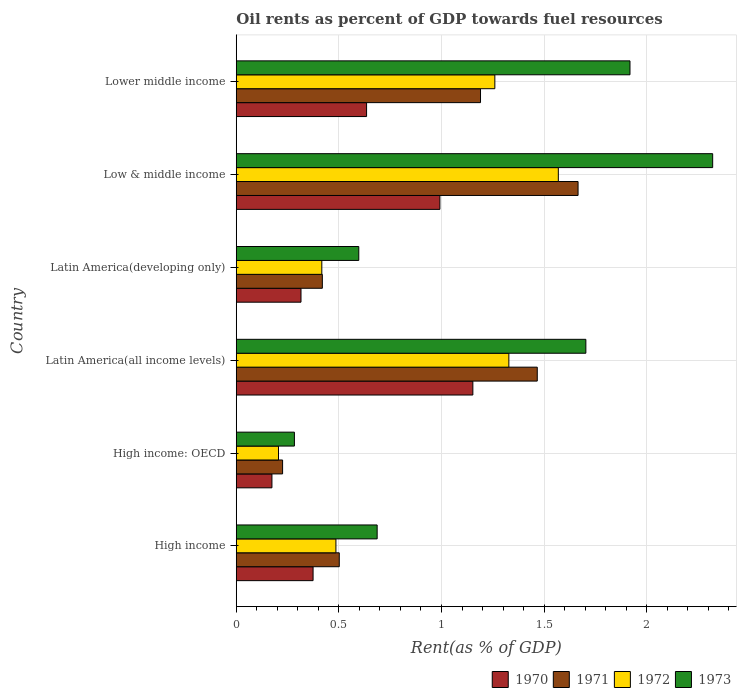How many groups of bars are there?
Offer a terse response. 6. How many bars are there on the 5th tick from the bottom?
Provide a succinct answer. 4. What is the label of the 4th group of bars from the top?
Make the answer very short. Latin America(all income levels). In how many cases, is the number of bars for a given country not equal to the number of legend labels?
Your response must be concise. 0. What is the oil rent in 1972 in Lower middle income?
Your response must be concise. 1.26. Across all countries, what is the maximum oil rent in 1972?
Offer a very short reply. 1.57. Across all countries, what is the minimum oil rent in 1970?
Your answer should be compact. 0.17. In which country was the oil rent in 1971 maximum?
Your answer should be compact. Low & middle income. In which country was the oil rent in 1972 minimum?
Make the answer very short. High income: OECD. What is the total oil rent in 1972 in the graph?
Offer a terse response. 5.27. What is the difference between the oil rent in 1973 in High income and that in Lower middle income?
Your answer should be compact. -1.23. What is the difference between the oil rent in 1971 in Latin America(developing only) and the oil rent in 1972 in High income: OECD?
Your response must be concise. 0.21. What is the average oil rent in 1972 per country?
Keep it short and to the point. 0.88. What is the difference between the oil rent in 1970 and oil rent in 1973 in High income?
Your answer should be compact. -0.31. In how many countries, is the oil rent in 1972 greater than 0.4 %?
Offer a very short reply. 5. What is the ratio of the oil rent in 1970 in Latin America(developing only) to that in Lower middle income?
Your answer should be compact. 0.5. Is the oil rent in 1972 in High income: OECD less than that in Low & middle income?
Provide a short and direct response. Yes. What is the difference between the highest and the second highest oil rent in 1970?
Offer a very short reply. 0.16. What is the difference between the highest and the lowest oil rent in 1971?
Provide a succinct answer. 1.44. In how many countries, is the oil rent in 1971 greater than the average oil rent in 1971 taken over all countries?
Your answer should be very brief. 3. Is it the case that in every country, the sum of the oil rent in 1972 and oil rent in 1971 is greater than the sum of oil rent in 1973 and oil rent in 1970?
Your answer should be very brief. No. What does the 1st bar from the top in High income represents?
Your response must be concise. 1973. What does the 2nd bar from the bottom in High income: OECD represents?
Give a very brief answer. 1971. Is it the case that in every country, the sum of the oil rent in 1972 and oil rent in 1970 is greater than the oil rent in 1973?
Offer a very short reply. No. How many bars are there?
Your response must be concise. 24. Are all the bars in the graph horizontal?
Your answer should be very brief. Yes. How many countries are there in the graph?
Your response must be concise. 6. What is the difference between two consecutive major ticks on the X-axis?
Ensure brevity in your answer.  0.5. How many legend labels are there?
Offer a terse response. 4. What is the title of the graph?
Your response must be concise. Oil rents as percent of GDP towards fuel resources. What is the label or title of the X-axis?
Provide a succinct answer. Rent(as % of GDP). What is the Rent(as % of GDP) in 1970 in High income?
Offer a terse response. 0.37. What is the Rent(as % of GDP) of 1971 in High income?
Provide a short and direct response. 0.5. What is the Rent(as % of GDP) in 1972 in High income?
Provide a succinct answer. 0.49. What is the Rent(as % of GDP) of 1973 in High income?
Ensure brevity in your answer.  0.69. What is the Rent(as % of GDP) of 1970 in High income: OECD?
Give a very brief answer. 0.17. What is the Rent(as % of GDP) in 1971 in High income: OECD?
Your answer should be compact. 0.23. What is the Rent(as % of GDP) in 1972 in High income: OECD?
Provide a short and direct response. 0.21. What is the Rent(as % of GDP) in 1973 in High income: OECD?
Give a very brief answer. 0.28. What is the Rent(as % of GDP) of 1970 in Latin America(all income levels)?
Your response must be concise. 1.15. What is the Rent(as % of GDP) in 1971 in Latin America(all income levels)?
Give a very brief answer. 1.47. What is the Rent(as % of GDP) in 1972 in Latin America(all income levels)?
Offer a very short reply. 1.33. What is the Rent(as % of GDP) in 1973 in Latin America(all income levels)?
Provide a short and direct response. 1.7. What is the Rent(as % of GDP) of 1970 in Latin America(developing only)?
Your answer should be compact. 0.32. What is the Rent(as % of GDP) in 1971 in Latin America(developing only)?
Provide a succinct answer. 0.42. What is the Rent(as % of GDP) in 1972 in Latin America(developing only)?
Offer a terse response. 0.42. What is the Rent(as % of GDP) in 1973 in Latin America(developing only)?
Provide a succinct answer. 0.6. What is the Rent(as % of GDP) in 1970 in Low & middle income?
Your response must be concise. 0.99. What is the Rent(as % of GDP) in 1971 in Low & middle income?
Your answer should be very brief. 1.67. What is the Rent(as % of GDP) in 1972 in Low & middle income?
Your answer should be very brief. 1.57. What is the Rent(as % of GDP) of 1973 in Low & middle income?
Ensure brevity in your answer.  2.32. What is the Rent(as % of GDP) in 1970 in Lower middle income?
Provide a succinct answer. 0.63. What is the Rent(as % of GDP) in 1971 in Lower middle income?
Your answer should be compact. 1.19. What is the Rent(as % of GDP) of 1972 in Lower middle income?
Your response must be concise. 1.26. What is the Rent(as % of GDP) in 1973 in Lower middle income?
Provide a succinct answer. 1.92. Across all countries, what is the maximum Rent(as % of GDP) in 1970?
Your answer should be compact. 1.15. Across all countries, what is the maximum Rent(as % of GDP) in 1971?
Keep it short and to the point. 1.67. Across all countries, what is the maximum Rent(as % of GDP) of 1972?
Ensure brevity in your answer.  1.57. Across all countries, what is the maximum Rent(as % of GDP) of 1973?
Your answer should be compact. 2.32. Across all countries, what is the minimum Rent(as % of GDP) of 1970?
Give a very brief answer. 0.17. Across all countries, what is the minimum Rent(as % of GDP) of 1971?
Keep it short and to the point. 0.23. Across all countries, what is the minimum Rent(as % of GDP) of 1972?
Provide a short and direct response. 0.21. Across all countries, what is the minimum Rent(as % of GDP) of 1973?
Your response must be concise. 0.28. What is the total Rent(as % of GDP) in 1970 in the graph?
Your response must be concise. 3.64. What is the total Rent(as % of GDP) of 1971 in the graph?
Offer a very short reply. 5.47. What is the total Rent(as % of GDP) of 1972 in the graph?
Your answer should be very brief. 5.27. What is the total Rent(as % of GDP) of 1973 in the graph?
Ensure brevity in your answer.  7.51. What is the difference between the Rent(as % of GDP) in 1970 in High income and that in High income: OECD?
Offer a very short reply. 0.2. What is the difference between the Rent(as % of GDP) in 1971 in High income and that in High income: OECD?
Your answer should be very brief. 0.28. What is the difference between the Rent(as % of GDP) of 1972 in High income and that in High income: OECD?
Offer a terse response. 0.28. What is the difference between the Rent(as % of GDP) of 1973 in High income and that in High income: OECD?
Your response must be concise. 0.4. What is the difference between the Rent(as % of GDP) in 1970 in High income and that in Latin America(all income levels)?
Your answer should be compact. -0.78. What is the difference between the Rent(as % of GDP) of 1971 in High income and that in Latin America(all income levels)?
Offer a terse response. -0.96. What is the difference between the Rent(as % of GDP) in 1972 in High income and that in Latin America(all income levels)?
Offer a very short reply. -0.84. What is the difference between the Rent(as % of GDP) in 1973 in High income and that in Latin America(all income levels)?
Ensure brevity in your answer.  -1.02. What is the difference between the Rent(as % of GDP) of 1970 in High income and that in Latin America(developing only)?
Offer a very short reply. 0.06. What is the difference between the Rent(as % of GDP) of 1971 in High income and that in Latin America(developing only)?
Your response must be concise. 0.08. What is the difference between the Rent(as % of GDP) in 1972 in High income and that in Latin America(developing only)?
Your answer should be compact. 0.07. What is the difference between the Rent(as % of GDP) of 1973 in High income and that in Latin America(developing only)?
Keep it short and to the point. 0.09. What is the difference between the Rent(as % of GDP) of 1970 in High income and that in Low & middle income?
Offer a terse response. -0.62. What is the difference between the Rent(as % of GDP) of 1971 in High income and that in Low & middle income?
Provide a short and direct response. -1.16. What is the difference between the Rent(as % of GDP) of 1972 in High income and that in Low & middle income?
Give a very brief answer. -1.08. What is the difference between the Rent(as % of GDP) in 1973 in High income and that in Low & middle income?
Provide a short and direct response. -1.63. What is the difference between the Rent(as % of GDP) of 1970 in High income and that in Lower middle income?
Your response must be concise. -0.26. What is the difference between the Rent(as % of GDP) in 1971 in High income and that in Lower middle income?
Give a very brief answer. -0.69. What is the difference between the Rent(as % of GDP) of 1972 in High income and that in Lower middle income?
Your answer should be compact. -0.77. What is the difference between the Rent(as % of GDP) of 1973 in High income and that in Lower middle income?
Provide a short and direct response. -1.23. What is the difference between the Rent(as % of GDP) of 1970 in High income: OECD and that in Latin America(all income levels)?
Keep it short and to the point. -0.98. What is the difference between the Rent(as % of GDP) of 1971 in High income: OECD and that in Latin America(all income levels)?
Offer a very short reply. -1.24. What is the difference between the Rent(as % of GDP) of 1972 in High income: OECD and that in Latin America(all income levels)?
Provide a succinct answer. -1.12. What is the difference between the Rent(as % of GDP) of 1973 in High income: OECD and that in Latin America(all income levels)?
Ensure brevity in your answer.  -1.42. What is the difference between the Rent(as % of GDP) of 1970 in High income: OECD and that in Latin America(developing only)?
Keep it short and to the point. -0.14. What is the difference between the Rent(as % of GDP) in 1971 in High income: OECD and that in Latin America(developing only)?
Offer a very short reply. -0.19. What is the difference between the Rent(as % of GDP) of 1972 in High income: OECD and that in Latin America(developing only)?
Give a very brief answer. -0.21. What is the difference between the Rent(as % of GDP) of 1973 in High income: OECD and that in Latin America(developing only)?
Keep it short and to the point. -0.31. What is the difference between the Rent(as % of GDP) of 1970 in High income: OECD and that in Low & middle income?
Your response must be concise. -0.82. What is the difference between the Rent(as % of GDP) of 1971 in High income: OECD and that in Low & middle income?
Provide a short and direct response. -1.44. What is the difference between the Rent(as % of GDP) in 1972 in High income: OECD and that in Low & middle income?
Ensure brevity in your answer.  -1.36. What is the difference between the Rent(as % of GDP) of 1973 in High income: OECD and that in Low & middle income?
Give a very brief answer. -2.04. What is the difference between the Rent(as % of GDP) in 1970 in High income: OECD and that in Lower middle income?
Your answer should be compact. -0.46. What is the difference between the Rent(as % of GDP) in 1971 in High income: OECD and that in Lower middle income?
Keep it short and to the point. -0.96. What is the difference between the Rent(as % of GDP) of 1972 in High income: OECD and that in Lower middle income?
Your answer should be very brief. -1.05. What is the difference between the Rent(as % of GDP) in 1973 in High income: OECD and that in Lower middle income?
Provide a succinct answer. -1.64. What is the difference between the Rent(as % of GDP) in 1970 in Latin America(all income levels) and that in Latin America(developing only)?
Give a very brief answer. 0.84. What is the difference between the Rent(as % of GDP) in 1971 in Latin America(all income levels) and that in Latin America(developing only)?
Provide a succinct answer. 1.05. What is the difference between the Rent(as % of GDP) in 1972 in Latin America(all income levels) and that in Latin America(developing only)?
Your answer should be very brief. 0.91. What is the difference between the Rent(as % of GDP) in 1973 in Latin America(all income levels) and that in Latin America(developing only)?
Keep it short and to the point. 1.11. What is the difference between the Rent(as % of GDP) of 1970 in Latin America(all income levels) and that in Low & middle income?
Your response must be concise. 0.16. What is the difference between the Rent(as % of GDP) of 1971 in Latin America(all income levels) and that in Low & middle income?
Give a very brief answer. -0.2. What is the difference between the Rent(as % of GDP) of 1972 in Latin America(all income levels) and that in Low & middle income?
Keep it short and to the point. -0.24. What is the difference between the Rent(as % of GDP) of 1973 in Latin America(all income levels) and that in Low & middle income?
Your answer should be compact. -0.62. What is the difference between the Rent(as % of GDP) of 1970 in Latin America(all income levels) and that in Lower middle income?
Offer a very short reply. 0.52. What is the difference between the Rent(as % of GDP) in 1971 in Latin America(all income levels) and that in Lower middle income?
Provide a succinct answer. 0.28. What is the difference between the Rent(as % of GDP) of 1972 in Latin America(all income levels) and that in Lower middle income?
Make the answer very short. 0.07. What is the difference between the Rent(as % of GDP) of 1973 in Latin America(all income levels) and that in Lower middle income?
Offer a very short reply. -0.21. What is the difference between the Rent(as % of GDP) of 1970 in Latin America(developing only) and that in Low & middle income?
Ensure brevity in your answer.  -0.68. What is the difference between the Rent(as % of GDP) in 1971 in Latin America(developing only) and that in Low & middle income?
Offer a terse response. -1.25. What is the difference between the Rent(as % of GDP) in 1972 in Latin America(developing only) and that in Low & middle income?
Your response must be concise. -1.15. What is the difference between the Rent(as % of GDP) in 1973 in Latin America(developing only) and that in Low & middle income?
Give a very brief answer. -1.72. What is the difference between the Rent(as % of GDP) of 1970 in Latin America(developing only) and that in Lower middle income?
Provide a succinct answer. -0.32. What is the difference between the Rent(as % of GDP) in 1971 in Latin America(developing only) and that in Lower middle income?
Offer a terse response. -0.77. What is the difference between the Rent(as % of GDP) of 1972 in Latin America(developing only) and that in Lower middle income?
Your answer should be compact. -0.84. What is the difference between the Rent(as % of GDP) in 1973 in Latin America(developing only) and that in Lower middle income?
Make the answer very short. -1.32. What is the difference between the Rent(as % of GDP) of 1970 in Low & middle income and that in Lower middle income?
Offer a terse response. 0.36. What is the difference between the Rent(as % of GDP) of 1971 in Low & middle income and that in Lower middle income?
Offer a very short reply. 0.48. What is the difference between the Rent(as % of GDP) of 1972 in Low & middle income and that in Lower middle income?
Give a very brief answer. 0.31. What is the difference between the Rent(as % of GDP) of 1973 in Low & middle income and that in Lower middle income?
Your response must be concise. 0.4. What is the difference between the Rent(as % of GDP) in 1970 in High income and the Rent(as % of GDP) in 1971 in High income: OECD?
Your response must be concise. 0.15. What is the difference between the Rent(as % of GDP) of 1970 in High income and the Rent(as % of GDP) of 1972 in High income: OECD?
Your answer should be very brief. 0.17. What is the difference between the Rent(as % of GDP) of 1970 in High income and the Rent(as % of GDP) of 1973 in High income: OECD?
Give a very brief answer. 0.09. What is the difference between the Rent(as % of GDP) in 1971 in High income and the Rent(as % of GDP) in 1972 in High income: OECD?
Offer a terse response. 0.3. What is the difference between the Rent(as % of GDP) of 1971 in High income and the Rent(as % of GDP) of 1973 in High income: OECD?
Provide a short and direct response. 0.22. What is the difference between the Rent(as % of GDP) of 1972 in High income and the Rent(as % of GDP) of 1973 in High income: OECD?
Your answer should be compact. 0.2. What is the difference between the Rent(as % of GDP) in 1970 in High income and the Rent(as % of GDP) in 1971 in Latin America(all income levels)?
Your answer should be compact. -1.09. What is the difference between the Rent(as % of GDP) in 1970 in High income and the Rent(as % of GDP) in 1972 in Latin America(all income levels)?
Your answer should be very brief. -0.95. What is the difference between the Rent(as % of GDP) of 1970 in High income and the Rent(as % of GDP) of 1973 in Latin America(all income levels)?
Give a very brief answer. -1.33. What is the difference between the Rent(as % of GDP) in 1971 in High income and the Rent(as % of GDP) in 1972 in Latin America(all income levels)?
Provide a short and direct response. -0.83. What is the difference between the Rent(as % of GDP) in 1971 in High income and the Rent(as % of GDP) in 1973 in Latin America(all income levels)?
Offer a very short reply. -1.2. What is the difference between the Rent(as % of GDP) of 1972 in High income and the Rent(as % of GDP) of 1973 in Latin America(all income levels)?
Offer a very short reply. -1.22. What is the difference between the Rent(as % of GDP) of 1970 in High income and the Rent(as % of GDP) of 1971 in Latin America(developing only)?
Offer a very short reply. -0.05. What is the difference between the Rent(as % of GDP) of 1970 in High income and the Rent(as % of GDP) of 1972 in Latin America(developing only)?
Your answer should be compact. -0.04. What is the difference between the Rent(as % of GDP) in 1970 in High income and the Rent(as % of GDP) in 1973 in Latin America(developing only)?
Offer a terse response. -0.22. What is the difference between the Rent(as % of GDP) of 1971 in High income and the Rent(as % of GDP) of 1972 in Latin America(developing only)?
Your response must be concise. 0.09. What is the difference between the Rent(as % of GDP) in 1971 in High income and the Rent(as % of GDP) in 1973 in Latin America(developing only)?
Your answer should be compact. -0.1. What is the difference between the Rent(as % of GDP) in 1972 in High income and the Rent(as % of GDP) in 1973 in Latin America(developing only)?
Give a very brief answer. -0.11. What is the difference between the Rent(as % of GDP) in 1970 in High income and the Rent(as % of GDP) in 1971 in Low & middle income?
Give a very brief answer. -1.29. What is the difference between the Rent(as % of GDP) in 1970 in High income and the Rent(as % of GDP) in 1972 in Low & middle income?
Provide a short and direct response. -1.19. What is the difference between the Rent(as % of GDP) of 1970 in High income and the Rent(as % of GDP) of 1973 in Low & middle income?
Ensure brevity in your answer.  -1.95. What is the difference between the Rent(as % of GDP) of 1971 in High income and the Rent(as % of GDP) of 1972 in Low & middle income?
Make the answer very short. -1.07. What is the difference between the Rent(as % of GDP) of 1971 in High income and the Rent(as % of GDP) of 1973 in Low & middle income?
Keep it short and to the point. -1.82. What is the difference between the Rent(as % of GDP) of 1972 in High income and the Rent(as % of GDP) of 1973 in Low & middle income?
Make the answer very short. -1.84. What is the difference between the Rent(as % of GDP) in 1970 in High income and the Rent(as % of GDP) in 1971 in Lower middle income?
Your answer should be compact. -0.82. What is the difference between the Rent(as % of GDP) in 1970 in High income and the Rent(as % of GDP) in 1972 in Lower middle income?
Your response must be concise. -0.89. What is the difference between the Rent(as % of GDP) in 1970 in High income and the Rent(as % of GDP) in 1973 in Lower middle income?
Your answer should be very brief. -1.54. What is the difference between the Rent(as % of GDP) in 1971 in High income and the Rent(as % of GDP) in 1972 in Lower middle income?
Offer a terse response. -0.76. What is the difference between the Rent(as % of GDP) of 1971 in High income and the Rent(as % of GDP) of 1973 in Lower middle income?
Provide a short and direct response. -1.42. What is the difference between the Rent(as % of GDP) in 1972 in High income and the Rent(as % of GDP) in 1973 in Lower middle income?
Offer a terse response. -1.43. What is the difference between the Rent(as % of GDP) in 1970 in High income: OECD and the Rent(as % of GDP) in 1971 in Latin America(all income levels)?
Your response must be concise. -1.29. What is the difference between the Rent(as % of GDP) of 1970 in High income: OECD and the Rent(as % of GDP) of 1972 in Latin America(all income levels)?
Give a very brief answer. -1.15. What is the difference between the Rent(as % of GDP) of 1970 in High income: OECD and the Rent(as % of GDP) of 1973 in Latin America(all income levels)?
Offer a very short reply. -1.53. What is the difference between the Rent(as % of GDP) of 1971 in High income: OECD and the Rent(as % of GDP) of 1972 in Latin America(all income levels)?
Your response must be concise. -1.1. What is the difference between the Rent(as % of GDP) in 1971 in High income: OECD and the Rent(as % of GDP) in 1973 in Latin America(all income levels)?
Make the answer very short. -1.48. What is the difference between the Rent(as % of GDP) in 1972 in High income: OECD and the Rent(as % of GDP) in 1973 in Latin America(all income levels)?
Make the answer very short. -1.5. What is the difference between the Rent(as % of GDP) of 1970 in High income: OECD and the Rent(as % of GDP) of 1971 in Latin America(developing only)?
Your response must be concise. -0.25. What is the difference between the Rent(as % of GDP) of 1970 in High income: OECD and the Rent(as % of GDP) of 1972 in Latin America(developing only)?
Ensure brevity in your answer.  -0.24. What is the difference between the Rent(as % of GDP) in 1970 in High income: OECD and the Rent(as % of GDP) in 1973 in Latin America(developing only)?
Provide a succinct answer. -0.42. What is the difference between the Rent(as % of GDP) of 1971 in High income: OECD and the Rent(as % of GDP) of 1972 in Latin America(developing only)?
Your answer should be compact. -0.19. What is the difference between the Rent(as % of GDP) of 1971 in High income: OECD and the Rent(as % of GDP) of 1973 in Latin America(developing only)?
Offer a terse response. -0.37. What is the difference between the Rent(as % of GDP) of 1972 in High income: OECD and the Rent(as % of GDP) of 1973 in Latin America(developing only)?
Provide a short and direct response. -0.39. What is the difference between the Rent(as % of GDP) of 1970 in High income: OECD and the Rent(as % of GDP) of 1971 in Low & middle income?
Make the answer very short. -1.49. What is the difference between the Rent(as % of GDP) of 1970 in High income: OECD and the Rent(as % of GDP) of 1972 in Low & middle income?
Make the answer very short. -1.4. What is the difference between the Rent(as % of GDP) of 1970 in High income: OECD and the Rent(as % of GDP) of 1973 in Low & middle income?
Provide a succinct answer. -2.15. What is the difference between the Rent(as % of GDP) in 1971 in High income: OECD and the Rent(as % of GDP) in 1972 in Low & middle income?
Keep it short and to the point. -1.34. What is the difference between the Rent(as % of GDP) of 1971 in High income: OECD and the Rent(as % of GDP) of 1973 in Low & middle income?
Keep it short and to the point. -2.1. What is the difference between the Rent(as % of GDP) in 1972 in High income: OECD and the Rent(as % of GDP) in 1973 in Low & middle income?
Give a very brief answer. -2.12. What is the difference between the Rent(as % of GDP) of 1970 in High income: OECD and the Rent(as % of GDP) of 1971 in Lower middle income?
Offer a terse response. -1.02. What is the difference between the Rent(as % of GDP) of 1970 in High income: OECD and the Rent(as % of GDP) of 1972 in Lower middle income?
Your response must be concise. -1.09. What is the difference between the Rent(as % of GDP) of 1970 in High income: OECD and the Rent(as % of GDP) of 1973 in Lower middle income?
Give a very brief answer. -1.74. What is the difference between the Rent(as % of GDP) in 1971 in High income: OECD and the Rent(as % of GDP) in 1972 in Lower middle income?
Provide a short and direct response. -1.03. What is the difference between the Rent(as % of GDP) in 1971 in High income: OECD and the Rent(as % of GDP) in 1973 in Lower middle income?
Your response must be concise. -1.69. What is the difference between the Rent(as % of GDP) of 1972 in High income: OECD and the Rent(as % of GDP) of 1973 in Lower middle income?
Your response must be concise. -1.71. What is the difference between the Rent(as % of GDP) of 1970 in Latin America(all income levels) and the Rent(as % of GDP) of 1971 in Latin America(developing only)?
Provide a short and direct response. 0.73. What is the difference between the Rent(as % of GDP) in 1970 in Latin America(all income levels) and the Rent(as % of GDP) in 1972 in Latin America(developing only)?
Ensure brevity in your answer.  0.74. What is the difference between the Rent(as % of GDP) of 1970 in Latin America(all income levels) and the Rent(as % of GDP) of 1973 in Latin America(developing only)?
Keep it short and to the point. 0.56. What is the difference between the Rent(as % of GDP) of 1971 in Latin America(all income levels) and the Rent(as % of GDP) of 1972 in Latin America(developing only)?
Provide a short and direct response. 1.05. What is the difference between the Rent(as % of GDP) of 1971 in Latin America(all income levels) and the Rent(as % of GDP) of 1973 in Latin America(developing only)?
Keep it short and to the point. 0.87. What is the difference between the Rent(as % of GDP) in 1972 in Latin America(all income levels) and the Rent(as % of GDP) in 1973 in Latin America(developing only)?
Your answer should be very brief. 0.73. What is the difference between the Rent(as % of GDP) of 1970 in Latin America(all income levels) and the Rent(as % of GDP) of 1971 in Low & middle income?
Your response must be concise. -0.51. What is the difference between the Rent(as % of GDP) in 1970 in Latin America(all income levels) and the Rent(as % of GDP) in 1972 in Low & middle income?
Make the answer very short. -0.42. What is the difference between the Rent(as % of GDP) in 1970 in Latin America(all income levels) and the Rent(as % of GDP) in 1973 in Low & middle income?
Your response must be concise. -1.17. What is the difference between the Rent(as % of GDP) in 1971 in Latin America(all income levels) and the Rent(as % of GDP) in 1972 in Low & middle income?
Provide a short and direct response. -0.1. What is the difference between the Rent(as % of GDP) of 1971 in Latin America(all income levels) and the Rent(as % of GDP) of 1973 in Low & middle income?
Give a very brief answer. -0.85. What is the difference between the Rent(as % of GDP) of 1972 in Latin America(all income levels) and the Rent(as % of GDP) of 1973 in Low & middle income?
Provide a succinct answer. -0.99. What is the difference between the Rent(as % of GDP) of 1970 in Latin America(all income levels) and the Rent(as % of GDP) of 1971 in Lower middle income?
Offer a very short reply. -0.04. What is the difference between the Rent(as % of GDP) in 1970 in Latin America(all income levels) and the Rent(as % of GDP) in 1972 in Lower middle income?
Ensure brevity in your answer.  -0.11. What is the difference between the Rent(as % of GDP) of 1970 in Latin America(all income levels) and the Rent(as % of GDP) of 1973 in Lower middle income?
Your answer should be very brief. -0.77. What is the difference between the Rent(as % of GDP) in 1971 in Latin America(all income levels) and the Rent(as % of GDP) in 1972 in Lower middle income?
Your answer should be compact. 0.21. What is the difference between the Rent(as % of GDP) of 1971 in Latin America(all income levels) and the Rent(as % of GDP) of 1973 in Lower middle income?
Your answer should be very brief. -0.45. What is the difference between the Rent(as % of GDP) in 1972 in Latin America(all income levels) and the Rent(as % of GDP) in 1973 in Lower middle income?
Your answer should be very brief. -0.59. What is the difference between the Rent(as % of GDP) in 1970 in Latin America(developing only) and the Rent(as % of GDP) in 1971 in Low & middle income?
Keep it short and to the point. -1.35. What is the difference between the Rent(as % of GDP) of 1970 in Latin America(developing only) and the Rent(as % of GDP) of 1972 in Low & middle income?
Make the answer very short. -1.25. What is the difference between the Rent(as % of GDP) in 1970 in Latin America(developing only) and the Rent(as % of GDP) in 1973 in Low & middle income?
Keep it short and to the point. -2.01. What is the difference between the Rent(as % of GDP) of 1971 in Latin America(developing only) and the Rent(as % of GDP) of 1972 in Low & middle income?
Keep it short and to the point. -1.15. What is the difference between the Rent(as % of GDP) in 1971 in Latin America(developing only) and the Rent(as % of GDP) in 1973 in Low & middle income?
Make the answer very short. -1.9. What is the difference between the Rent(as % of GDP) of 1972 in Latin America(developing only) and the Rent(as % of GDP) of 1973 in Low & middle income?
Offer a terse response. -1.9. What is the difference between the Rent(as % of GDP) of 1970 in Latin America(developing only) and the Rent(as % of GDP) of 1971 in Lower middle income?
Your response must be concise. -0.87. What is the difference between the Rent(as % of GDP) of 1970 in Latin America(developing only) and the Rent(as % of GDP) of 1972 in Lower middle income?
Provide a short and direct response. -0.94. What is the difference between the Rent(as % of GDP) of 1970 in Latin America(developing only) and the Rent(as % of GDP) of 1973 in Lower middle income?
Give a very brief answer. -1.6. What is the difference between the Rent(as % of GDP) in 1971 in Latin America(developing only) and the Rent(as % of GDP) in 1972 in Lower middle income?
Your answer should be compact. -0.84. What is the difference between the Rent(as % of GDP) in 1971 in Latin America(developing only) and the Rent(as % of GDP) in 1973 in Lower middle income?
Your answer should be very brief. -1.5. What is the difference between the Rent(as % of GDP) in 1972 in Latin America(developing only) and the Rent(as % of GDP) in 1973 in Lower middle income?
Your answer should be compact. -1.5. What is the difference between the Rent(as % of GDP) of 1970 in Low & middle income and the Rent(as % of GDP) of 1971 in Lower middle income?
Your response must be concise. -0.2. What is the difference between the Rent(as % of GDP) in 1970 in Low & middle income and the Rent(as % of GDP) in 1972 in Lower middle income?
Offer a very short reply. -0.27. What is the difference between the Rent(as % of GDP) of 1970 in Low & middle income and the Rent(as % of GDP) of 1973 in Lower middle income?
Ensure brevity in your answer.  -0.93. What is the difference between the Rent(as % of GDP) in 1971 in Low & middle income and the Rent(as % of GDP) in 1972 in Lower middle income?
Ensure brevity in your answer.  0.41. What is the difference between the Rent(as % of GDP) of 1971 in Low & middle income and the Rent(as % of GDP) of 1973 in Lower middle income?
Your answer should be compact. -0.25. What is the difference between the Rent(as % of GDP) of 1972 in Low & middle income and the Rent(as % of GDP) of 1973 in Lower middle income?
Provide a short and direct response. -0.35. What is the average Rent(as % of GDP) of 1970 per country?
Offer a terse response. 0.61. What is the average Rent(as % of GDP) of 1971 per country?
Your answer should be very brief. 0.91. What is the average Rent(as % of GDP) in 1972 per country?
Your answer should be compact. 0.88. What is the average Rent(as % of GDP) in 1973 per country?
Your response must be concise. 1.25. What is the difference between the Rent(as % of GDP) in 1970 and Rent(as % of GDP) in 1971 in High income?
Keep it short and to the point. -0.13. What is the difference between the Rent(as % of GDP) in 1970 and Rent(as % of GDP) in 1972 in High income?
Offer a very short reply. -0.11. What is the difference between the Rent(as % of GDP) in 1970 and Rent(as % of GDP) in 1973 in High income?
Your answer should be very brief. -0.31. What is the difference between the Rent(as % of GDP) in 1971 and Rent(as % of GDP) in 1972 in High income?
Your response must be concise. 0.02. What is the difference between the Rent(as % of GDP) of 1971 and Rent(as % of GDP) of 1973 in High income?
Provide a succinct answer. -0.18. What is the difference between the Rent(as % of GDP) in 1972 and Rent(as % of GDP) in 1973 in High income?
Your answer should be very brief. -0.2. What is the difference between the Rent(as % of GDP) of 1970 and Rent(as % of GDP) of 1971 in High income: OECD?
Provide a succinct answer. -0.05. What is the difference between the Rent(as % of GDP) in 1970 and Rent(as % of GDP) in 1972 in High income: OECD?
Give a very brief answer. -0.03. What is the difference between the Rent(as % of GDP) in 1970 and Rent(as % of GDP) in 1973 in High income: OECD?
Keep it short and to the point. -0.11. What is the difference between the Rent(as % of GDP) of 1971 and Rent(as % of GDP) of 1973 in High income: OECD?
Make the answer very short. -0.06. What is the difference between the Rent(as % of GDP) of 1972 and Rent(as % of GDP) of 1973 in High income: OECD?
Your response must be concise. -0.08. What is the difference between the Rent(as % of GDP) of 1970 and Rent(as % of GDP) of 1971 in Latin America(all income levels)?
Keep it short and to the point. -0.31. What is the difference between the Rent(as % of GDP) of 1970 and Rent(as % of GDP) of 1972 in Latin America(all income levels)?
Offer a terse response. -0.18. What is the difference between the Rent(as % of GDP) of 1970 and Rent(as % of GDP) of 1973 in Latin America(all income levels)?
Provide a succinct answer. -0.55. What is the difference between the Rent(as % of GDP) of 1971 and Rent(as % of GDP) of 1972 in Latin America(all income levels)?
Offer a very short reply. 0.14. What is the difference between the Rent(as % of GDP) in 1971 and Rent(as % of GDP) in 1973 in Latin America(all income levels)?
Provide a short and direct response. -0.24. What is the difference between the Rent(as % of GDP) in 1972 and Rent(as % of GDP) in 1973 in Latin America(all income levels)?
Provide a short and direct response. -0.38. What is the difference between the Rent(as % of GDP) of 1970 and Rent(as % of GDP) of 1971 in Latin America(developing only)?
Keep it short and to the point. -0.1. What is the difference between the Rent(as % of GDP) in 1970 and Rent(as % of GDP) in 1972 in Latin America(developing only)?
Your answer should be very brief. -0.1. What is the difference between the Rent(as % of GDP) in 1970 and Rent(as % of GDP) in 1973 in Latin America(developing only)?
Make the answer very short. -0.28. What is the difference between the Rent(as % of GDP) in 1971 and Rent(as % of GDP) in 1972 in Latin America(developing only)?
Your answer should be compact. 0. What is the difference between the Rent(as % of GDP) in 1971 and Rent(as % of GDP) in 1973 in Latin America(developing only)?
Ensure brevity in your answer.  -0.18. What is the difference between the Rent(as % of GDP) of 1972 and Rent(as % of GDP) of 1973 in Latin America(developing only)?
Give a very brief answer. -0.18. What is the difference between the Rent(as % of GDP) of 1970 and Rent(as % of GDP) of 1971 in Low & middle income?
Offer a very short reply. -0.67. What is the difference between the Rent(as % of GDP) of 1970 and Rent(as % of GDP) of 1972 in Low & middle income?
Provide a short and direct response. -0.58. What is the difference between the Rent(as % of GDP) of 1970 and Rent(as % of GDP) of 1973 in Low & middle income?
Keep it short and to the point. -1.33. What is the difference between the Rent(as % of GDP) of 1971 and Rent(as % of GDP) of 1972 in Low & middle income?
Make the answer very short. 0.1. What is the difference between the Rent(as % of GDP) of 1971 and Rent(as % of GDP) of 1973 in Low & middle income?
Offer a very short reply. -0.66. What is the difference between the Rent(as % of GDP) of 1972 and Rent(as % of GDP) of 1973 in Low & middle income?
Make the answer very short. -0.75. What is the difference between the Rent(as % of GDP) of 1970 and Rent(as % of GDP) of 1971 in Lower middle income?
Provide a succinct answer. -0.56. What is the difference between the Rent(as % of GDP) of 1970 and Rent(as % of GDP) of 1972 in Lower middle income?
Provide a short and direct response. -0.62. What is the difference between the Rent(as % of GDP) of 1970 and Rent(as % of GDP) of 1973 in Lower middle income?
Ensure brevity in your answer.  -1.28. What is the difference between the Rent(as % of GDP) of 1971 and Rent(as % of GDP) of 1972 in Lower middle income?
Provide a short and direct response. -0.07. What is the difference between the Rent(as % of GDP) of 1971 and Rent(as % of GDP) of 1973 in Lower middle income?
Offer a very short reply. -0.73. What is the difference between the Rent(as % of GDP) of 1972 and Rent(as % of GDP) of 1973 in Lower middle income?
Your response must be concise. -0.66. What is the ratio of the Rent(as % of GDP) in 1970 in High income to that in High income: OECD?
Provide a short and direct response. 2.15. What is the ratio of the Rent(as % of GDP) in 1971 in High income to that in High income: OECD?
Offer a terse response. 2.22. What is the ratio of the Rent(as % of GDP) of 1972 in High income to that in High income: OECD?
Your response must be concise. 2.36. What is the ratio of the Rent(as % of GDP) of 1973 in High income to that in High income: OECD?
Provide a short and direct response. 2.42. What is the ratio of the Rent(as % of GDP) in 1970 in High income to that in Latin America(all income levels)?
Your answer should be compact. 0.32. What is the ratio of the Rent(as % of GDP) in 1971 in High income to that in Latin America(all income levels)?
Give a very brief answer. 0.34. What is the ratio of the Rent(as % of GDP) in 1972 in High income to that in Latin America(all income levels)?
Offer a terse response. 0.37. What is the ratio of the Rent(as % of GDP) in 1973 in High income to that in Latin America(all income levels)?
Your response must be concise. 0.4. What is the ratio of the Rent(as % of GDP) of 1970 in High income to that in Latin America(developing only)?
Your answer should be compact. 1.19. What is the ratio of the Rent(as % of GDP) of 1971 in High income to that in Latin America(developing only)?
Give a very brief answer. 1.2. What is the ratio of the Rent(as % of GDP) in 1972 in High income to that in Latin America(developing only)?
Offer a terse response. 1.17. What is the ratio of the Rent(as % of GDP) in 1973 in High income to that in Latin America(developing only)?
Your answer should be compact. 1.15. What is the ratio of the Rent(as % of GDP) in 1970 in High income to that in Low & middle income?
Offer a very short reply. 0.38. What is the ratio of the Rent(as % of GDP) of 1971 in High income to that in Low & middle income?
Offer a very short reply. 0.3. What is the ratio of the Rent(as % of GDP) in 1972 in High income to that in Low & middle income?
Provide a short and direct response. 0.31. What is the ratio of the Rent(as % of GDP) in 1973 in High income to that in Low & middle income?
Provide a short and direct response. 0.3. What is the ratio of the Rent(as % of GDP) of 1970 in High income to that in Lower middle income?
Offer a terse response. 0.59. What is the ratio of the Rent(as % of GDP) in 1971 in High income to that in Lower middle income?
Provide a succinct answer. 0.42. What is the ratio of the Rent(as % of GDP) of 1972 in High income to that in Lower middle income?
Your answer should be very brief. 0.39. What is the ratio of the Rent(as % of GDP) of 1973 in High income to that in Lower middle income?
Your response must be concise. 0.36. What is the ratio of the Rent(as % of GDP) in 1970 in High income: OECD to that in Latin America(all income levels)?
Make the answer very short. 0.15. What is the ratio of the Rent(as % of GDP) in 1971 in High income: OECD to that in Latin America(all income levels)?
Offer a terse response. 0.15. What is the ratio of the Rent(as % of GDP) of 1972 in High income: OECD to that in Latin America(all income levels)?
Your answer should be compact. 0.15. What is the ratio of the Rent(as % of GDP) of 1973 in High income: OECD to that in Latin America(all income levels)?
Your answer should be very brief. 0.17. What is the ratio of the Rent(as % of GDP) in 1970 in High income: OECD to that in Latin America(developing only)?
Offer a terse response. 0.55. What is the ratio of the Rent(as % of GDP) of 1971 in High income: OECD to that in Latin America(developing only)?
Offer a very short reply. 0.54. What is the ratio of the Rent(as % of GDP) of 1972 in High income: OECD to that in Latin America(developing only)?
Your response must be concise. 0.49. What is the ratio of the Rent(as % of GDP) of 1973 in High income: OECD to that in Latin America(developing only)?
Ensure brevity in your answer.  0.47. What is the ratio of the Rent(as % of GDP) of 1970 in High income: OECD to that in Low & middle income?
Your answer should be compact. 0.18. What is the ratio of the Rent(as % of GDP) of 1971 in High income: OECD to that in Low & middle income?
Provide a short and direct response. 0.14. What is the ratio of the Rent(as % of GDP) in 1972 in High income: OECD to that in Low & middle income?
Keep it short and to the point. 0.13. What is the ratio of the Rent(as % of GDP) of 1973 in High income: OECD to that in Low & middle income?
Provide a short and direct response. 0.12. What is the ratio of the Rent(as % of GDP) of 1970 in High income: OECD to that in Lower middle income?
Offer a terse response. 0.27. What is the ratio of the Rent(as % of GDP) in 1971 in High income: OECD to that in Lower middle income?
Make the answer very short. 0.19. What is the ratio of the Rent(as % of GDP) in 1972 in High income: OECD to that in Lower middle income?
Ensure brevity in your answer.  0.16. What is the ratio of the Rent(as % of GDP) in 1973 in High income: OECD to that in Lower middle income?
Your answer should be very brief. 0.15. What is the ratio of the Rent(as % of GDP) in 1970 in Latin America(all income levels) to that in Latin America(developing only)?
Make the answer very short. 3.65. What is the ratio of the Rent(as % of GDP) of 1971 in Latin America(all income levels) to that in Latin America(developing only)?
Keep it short and to the point. 3.5. What is the ratio of the Rent(as % of GDP) of 1972 in Latin America(all income levels) to that in Latin America(developing only)?
Your answer should be compact. 3.19. What is the ratio of the Rent(as % of GDP) of 1973 in Latin America(all income levels) to that in Latin America(developing only)?
Offer a terse response. 2.85. What is the ratio of the Rent(as % of GDP) in 1970 in Latin America(all income levels) to that in Low & middle income?
Give a very brief answer. 1.16. What is the ratio of the Rent(as % of GDP) of 1971 in Latin America(all income levels) to that in Low & middle income?
Keep it short and to the point. 0.88. What is the ratio of the Rent(as % of GDP) in 1972 in Latin America(all income levels) to that in Low & middle income?
Offer a very short reply. 0.85. What is the ratio of the Rent(as % of GDP) of 1973 in Latin America(all income levels) to that in Low & middle income?
Your answer should be very brief. 0.73. What is the ratio of the Rent(as % of GDP) of 1970 in Latin America(all income levels) to that in Lower middle income?
Make the answer very short. 1.82. What is the ratio of the Rent(as % of GDP) in 1971 in Latin America(all income levels) to that in Lower middle income?
Make the answer very short. 1.23. What is the ratio of the Rent(as % of GDP) in 1972 in Latin America(all income levels) to that in Lower middle income?
Keep it short and to the point. 1.05. What is the ratio of the Rent(as % of GDP) in 1973 in Latin America(all income levels) to that in Lower middle income?
Provide a short and direct response. 0.89. What is the ratio of the Rent(as % of GDP) in 1970 in Latin America(developing only) to that in Low & middle income?
Provide a short and direct response. 0.32. What is the ratio of the Rent(as % of GDP) of 1971 in Latin America(developing only) to that in Low & middle income?
Provide a short and direct response. 0.25. What is the ratio of the Rent(as % of GDP) in 1972 in Latin America(developing only) to that in Low & middle income?
Give a very brief answer. 0.27. What is the ratio of the Rent(as % of GDP) of 1973 in Latin America(developing only) to that in Low & middle income?
Provide a short and direct response. 0.26. What is the ratio of the Rent(as % of GDP) in 1970 in Latin America(developing only) to that in Lower middle income?
Give a very brief answer. 0.5. What is the ratio of the Rent(as % of GDP) of 1971 in Latin America(developing only) to that in Lower middle income?
Your response must be concise. 0.35. What is the ratio of the Rent(as % of GDP) in 1972 in Latin America(developing only) to that in Lower middle income?
Offer a very short reply. 0.33. What is the ratio of the Rent(as % of GDP) of 1973 in Latin America(developing only) to that in Lower middle income?
Offer a terse response. 0.31. What is the ratio of the Rent(as % of GDP) of 1970 in Low & middle income to that in Lower middle income?
Offer a very short reply. 1.56. What is the ratio of the Rent(as % of GDP) of 1971 in Low & middle income to that in Lower middle income?
Provide a short and direct response. 1.4. What is the ratio of the Rent(as % of GDP) of 1972 in Low & middle income to that in Lower middle income?
Your response must be concise. 1.25. What is the ratio of the Rent(as % of GDP) of 1973 in Low & middle income to that in Lower middle income?
Provide a short and direct response. 1.21. What is the difference between the highest and the second highest Rent(as % of GDP) in 1970?
Your response must be concise. 0.16. What is the difference between the highest and the second highest Rent(as % of GDP) in 1971?
Keep it short and to the point. 0.2. What is the difference between the highest and the second highest Rent(as % of GDP) in 1972?
Offer a very short reply. 0.24. What is the difference between the highest and the second highest Rent(as % of GDP) of 1973?
Give a very brief answer. 0.4. What is the difference between the highest and the lowest Rent(as % of GDP) in 1970?
Provide a succinct answer. 0.98. What is the difference between the highest and the lowest Rent(as % of GDP) in 1971?
Ensure brevity in your answer.  1.44. What is the difference between the highest and the lowest Rent(as % of GDP) of 1972?
Give a very brief answer. 1.36. What is the difference between the highest and the lowest Rent(as % of GDP) of 1973?
Make the answer very short. 2.04. 